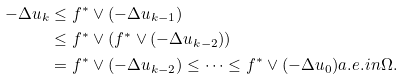<formula> <loc_0><loc_0><loc_500><loc_500>- \Delta u _ { k } & \leq f ^ { * } \vee ( - \Delta u _ { k - 1 } ) \\ & \leq f ^ { * } \vee \left ( f ^ { * } \vee ( - \Delta u _ { k - 2 } ) \right ) \\ & = f ^ { * } \vee ( - \Delta u _ { k - 2 } ) \leq \cdots \leq f ^ { * } \vee ( - \Delta u _ { 0 } ) a . e . i n \Omega .</formula> 